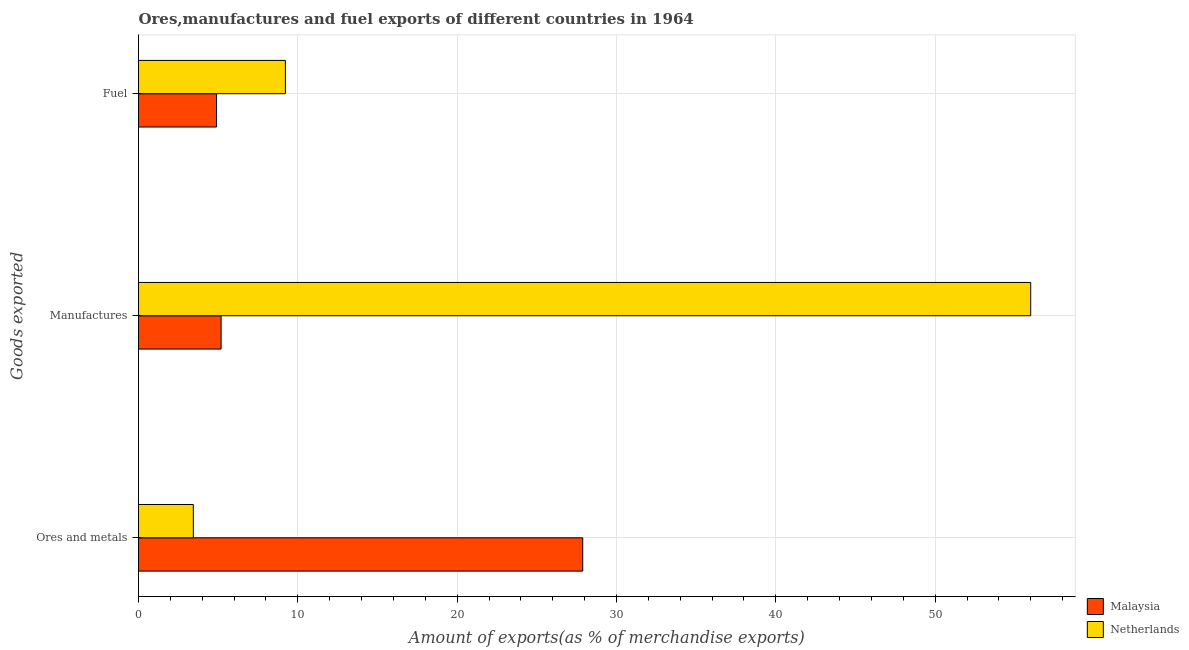How many different coloured bars are there?
Offer a terse response. 2. How many groups of bars are there?
Give a very brief answer. 3. Are the number of bars on each tick of the Y-axis equal?
Keep it short and to the point. Yes. How many bars are there on the 3rd tick from the top?
Your response must be concise. 2. How many bars are there on the 1st tick from the bottom?
Make the answer very short. 2. What is the label of the 3rd group of bars from the top?
Your answer should be very brief. Ores and metals. What is the percentage of ores and metals exports in Malaysia?
Your answer should be very brief. 27.88. Across all countries, what is the maximum percentage of manufactures exports?
Give a very brief answer. 56. Across all countries, what is the minimum percentage of fuel exports?
Offer a very short reply. 4.9. In which country was the percentage of fuel exports maximum?
Offer a very short reply. Netherlands. In which country was the percentage of fuel exports minimum?
Your answer should be compact. Malaysia. What is the total percentage of ores and metals exports in the graph?
Make the answer very short. 31.32. What is the difference between the percentage of manufactures exports in Netherlands and that in Malaysia?
Your answer should be very brief. 50.81. What is the difference between the percentage of manufactures exports in Malaysia and the percentage of ores and metals exports in Netherlands?
Make the answer very short. 1.74. What is the average percentage of ores and metals exports per country?
Make the answer very short. 15.66. What is the difference between the percentage of ores and metals exports and percentage of fuel exports in Malaysia?
Offer a very short reply. 22.98. What is the ratio of the percentage of ores and metals exports in Netherlands to that in Malaysia?
Your response must be concise. 0.12. Is the difference between the percentage of fuel exports in Malaysia and Netherlands greater than the difference between the percentage of manufactures exports in Malaysia and Netherlands?
Give a very brief answer. Yes. What is the difference between the highest and the second highest percentage of ores and metals exports?
Offer a very short reply. 24.44. What is the difference between the highest and the lowest percentage of manufactures exports?
Give a very brief answer. 50.81. In how many countries, is the percentage of fuel exports greater than the average percentage of fuel exports taken over all countries?
Offer a very short reply. 1. Is the sum of the percentage of manufactures exports in Netherlands and Malaysia greater than the maximum percentage of ores and metals exports across all countries?
Your answer should be very brief. Yes. What does the 1st bar from the bottom in Ores and metals represents?
Offer a terse response. Malaysia. How many bars are there?
Provide a short and direct response. 6. How many countries are there in the graph?
Offer a very short reply. 2. What is the difference between two consecutive major ticks on the X-axis?
Provide a succinct answer. 10. Does the graph contain grids?
Your answer should be very brief. Yes. How many legend labels are there?
Ensure brevity in your answer.  2. What is the title of the graph?
Keep it short and to the point. Ores,manufactures and fuel exports of different countries in 1964. Does "Philippines" appear as one of the legend labels in the graph?
Offer a terse response. No. What is the label or title of the X-axis?
Provide a short and direct response. Amount of exports(as % of merchandise exports). What is the label or title of the Y-axis?
Make the answer very short. Goods exported. What is the Amount of exports(as % of merchandise exports) in Malaysia in Ores and metals?
Provide a succinct answer. 27.88. What is the Amount of exports(as % of merchandise exports) in Netherlands in Ores and metals?
Make the answer very short. 3.44. What is the Amount of exports(as % of merchandise exports) in Malaysia in Manufactures?
Provide a short and direct response. 5.18. What is the Amount of exports(as % of merchandise exports) in Netherlands in Manufactures?
Offer a terse response. 56. What is the Amount of exports(as % of merchandise exports) of Malaysia in Fuel?
Make the answer very short. 4.9. What is the Amount of exports(as % of merchandise exports) of Netherlands in Fuel?
Your response must be concise. 9.22. Across all Goods exported, what is the maximum Amount of exports(as % of merchandise exports) of Malaysia?
Offer a very short reply. 27.88. Across all Goods exported, what is the maximum Amount of exports(as % of merchandise exports) of Netherlands?
Give a very brief answer. 56. Across all Goods exported, what is the minimum Amount of exports(as % of merchandise exports) in Malaysia?
Provide a succinct answer. 4.9. Across all Goods exported, what is the minimum Amount of exports(as % of merchandise exports) of Netherlands?
Offer a terse response. 3.44. What is the total Amount of exports(as % of merchandise exports) of Malaysia in the graph?
Your answer should be compact. 37.96. What is the total Amount of exports(as % of merchandise exports) of Netherlands in the graph?
Provide a succinct answer. 68.66. What is the difference between the Amount of exports(as % of merchandise exports) of Malaysia in Ores and metals and that in Manufactures?
Your answer should be very brief. 22.7. What is the difference between the Amount of exports(as % of merchandise exports) of Netherlands in Ores and metals and that in Manufactures?
Make the answer very short. -52.56. What is the difference between the Amount of exports(as % of merchandise exports) of Malaysia in Ores and metals and that in Fuel?
Your answer should be very brief. 22.98. What is the difference between the Amount of exports(as % of merchandise exports) of Netherlands in Ores and metals and that in Fuel?
Provide a short and direct response. -5.78. What is the difference between the Amount of exports(as % of merchandise exports) of Malaysia in Manufactures and that in Fuel?
Your response must be concise. 0.29. What is the difference between the Amount of exports(as % of merchandise exports) in Netherlands in Manufactures and that in Fuel?
Your answer should be compact. 46.78. What is the difference between the Amount of exports(as % of merchandise exports) in Malaysia in Ores and metals and the Amount of exports(as % of merchandise exports) in Netherlands in Manufactures?
Ensure brevity in your answer.  -28.12. What is the difference between the Amount of exports(as % of merchandise exports) of Malaysia in Ores and metals and the Amount of exports(as % of merchandise exports) of Netherlands in Fuel?
Your answer should be compact. 18.66. What is the difference between the Amount of exports(as % of merchandise exports) in Malaysia in Manufactures and the Amount of exports(as % of merchandise exports) in Netherlands in Fuel?
Keep it short and to the point. -4.04. What is the average Amount of exports(as % of merchandise exports) of Malaysia per Goods exported?
Ensure brevity in your answer.  12.65. What is the average Amount of exports(as % of merchandise exports) of Netherlands per Goods exported?
Provide a succinct answer. 22.89. What is the difference between the Amount of exports(as % of merchandise exports) in Malaysia and Amount of exports(as % of merchandise exports) in Netherlands in Ores and metals?
Provide a succinct answer. 24.44. What is the difference between the Amount of exports(as % of merchandise exports) of Malaysia and Amount of exports(as % of merchandise exports) of Netherlands in Manufactures?
Your response must be concise. -50.81. What is the difference between the Amount of exports(as % of merchandise exports) of Malaysia and Amount of exports(as % of merchandise exports) of Netherlands in Fuel?
Your response must be concise. -4.32. What is the ratio of the Amount of exports(as % of merchandise exports) of Malaysia in Ores and metals to that in Manufactures?
Your answer should be compact. 5.38. What is the ratio of the Amount of exports(as % of merchandise exports) in Netherlands in Ores and metals to that in Manufactures?
Give a very brief answer. 0.06. What is the ratio of the Amount of exports(as % of merchandise exports) in Malaysia in Ores and metals to that in Fuel?
Offer a terse response. 5.69. What is the ratio of the Amount of exports(as % of merchandise exports) in Netherlands in Ores and metals to that in Fuel?
Your response must be concise. 0.37. What is the ratio of the Amount of exports(as % of merchandise exports) of Malaysia in Manufactures to that in Fuel?
Your answer should be compact. 1.06. What is the ratio of the Amount of exports(as % of merchandise exports) of Netherlands in Manufactures to that in Fuel?
Provide a short and direct response. 6.07. What is the difference between the highest and the second highest Amount of exports(as % of merchandise exports) in Malaysia?
Offer a very short reply. 22.7. What is the difference between the highest and the second highest Amount of exports(as % of merchandise exports) of Netherlands?
Your answer should be compact. 46.78. What is the difference between the highest and the lowest Amount of exports(as % of merchandise exports) of Malaysia?
Make the answer very short. 22.98. What is the difference between the highest and the lowest Amount of exports(as % of merchandise exports) of Netherlands?
Offer a terse response. 52.56. 